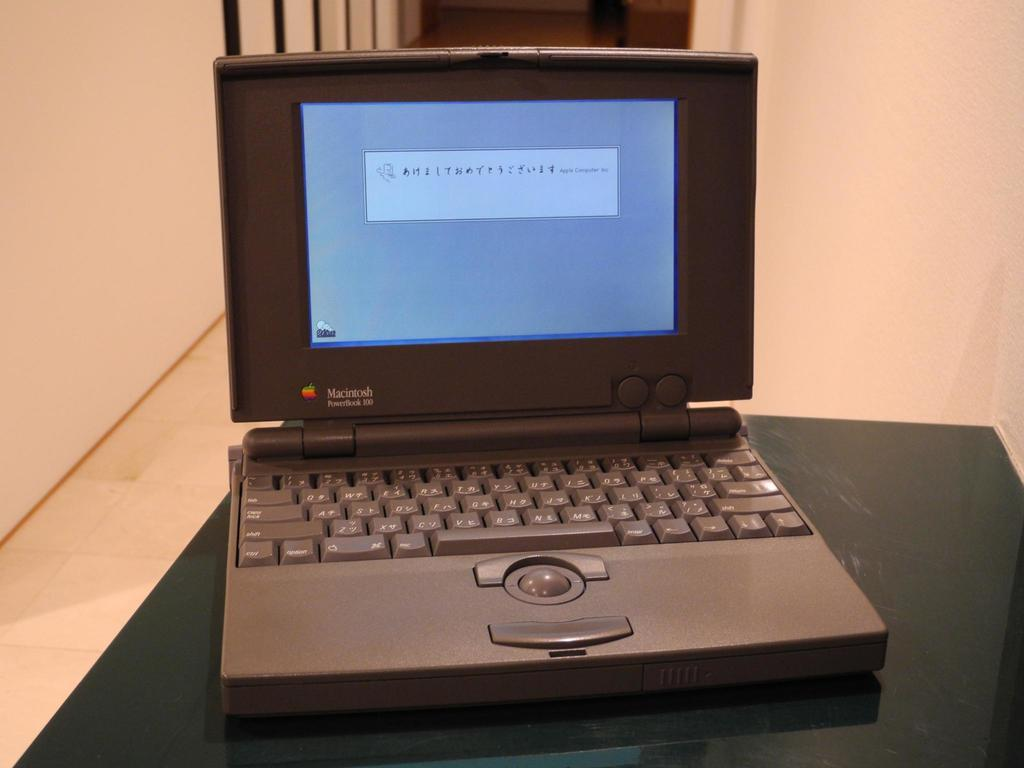Provide a one-sentence caption for the provided image. A Macintosh PowerBook 100 is turned on and is displaying a message. 